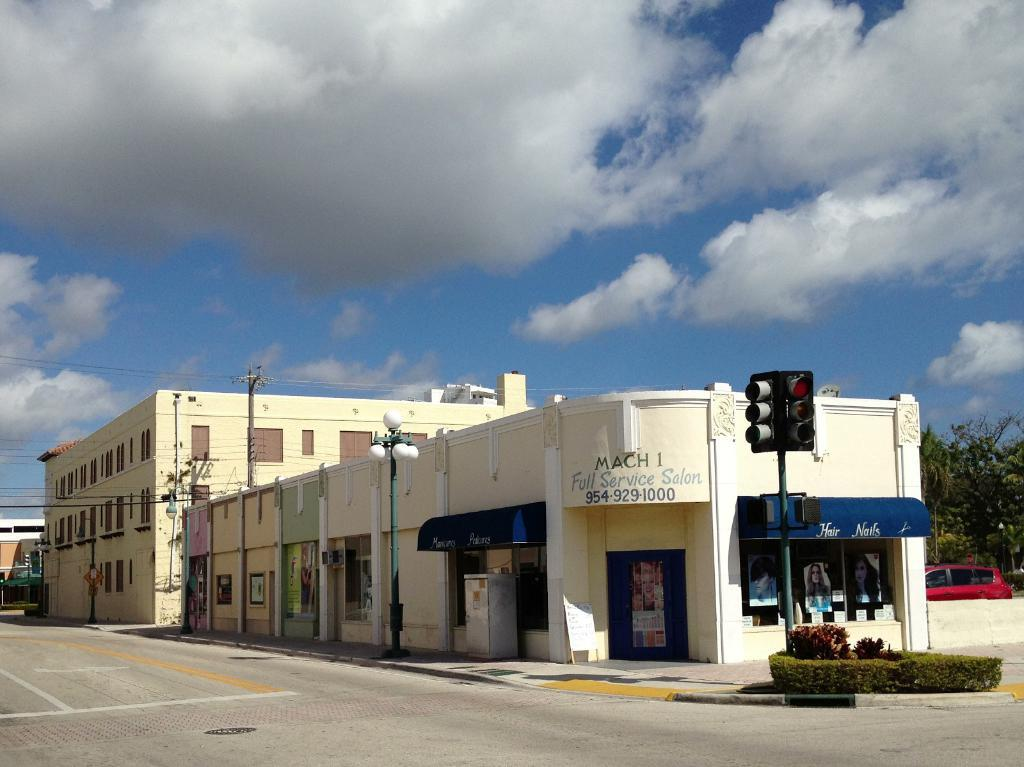What type of structures can be seen in the image? There are buildings in the image. What is the primary mode of transportation visible in the image? There is a vehicle in the image. What type of infrastructure is present in the image? There are roads, poles, traffic signals, and wires in the image. What type of natural elements can be seen in the image? There are plants and trees in the image. What type of man-made objects can be seen in the image? There are boards, posters, and lights in the image. What is visible in the background of the image? The sky is visible in the background of the image, with clouds present. Can you tell me how many slaves are depicted in the image? There are no slaves present in the image. What type of brain activity can be observed in the image? There is no brain activity depicted in the image. 